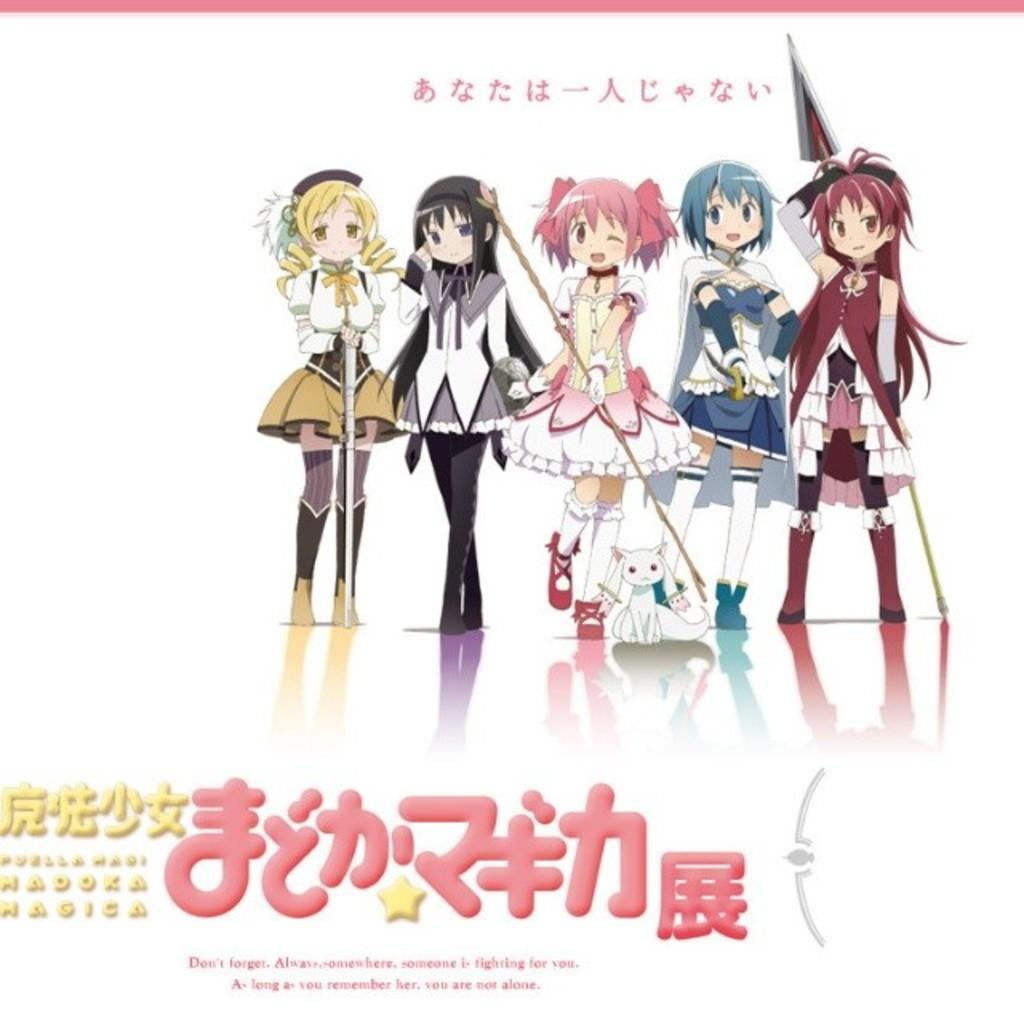What is featured in the image? There is a poster in the image. What type of images are on the poster? The poster contains cartoon images. Is there any text on the poster? Yes, there is text at the bottom of the poster. How many umbrellas are shown in the cartoon images on the poster? There is no mention of umbrellas in the image or the provided facts, so we cannot determine the number of umbrellas shown. 